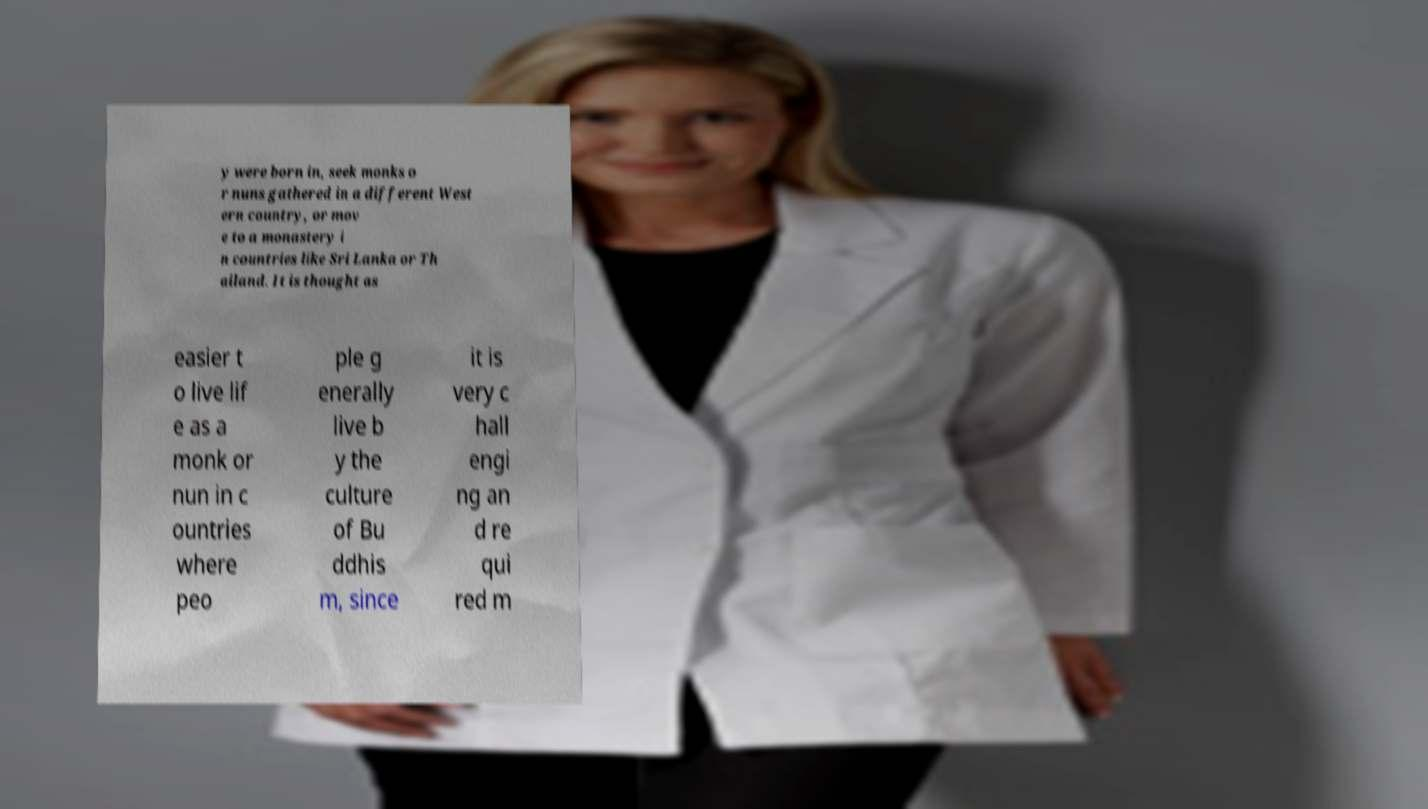Can you read and provide the text displayed in the image?This photo seems to have some interesting text. Can you extract and type it out for me? y were born in, seek monks o r nuns gathered in a different West ern country, or mov e to a monastery i n countries like Sri Lanka or Th ailand. It is thought as easier t o live lif e as a monk or nun in c ountries where peo ple g enerally live b y the culture of Bu ddhis m, since it is very c hall engi ng an d re qui red m 